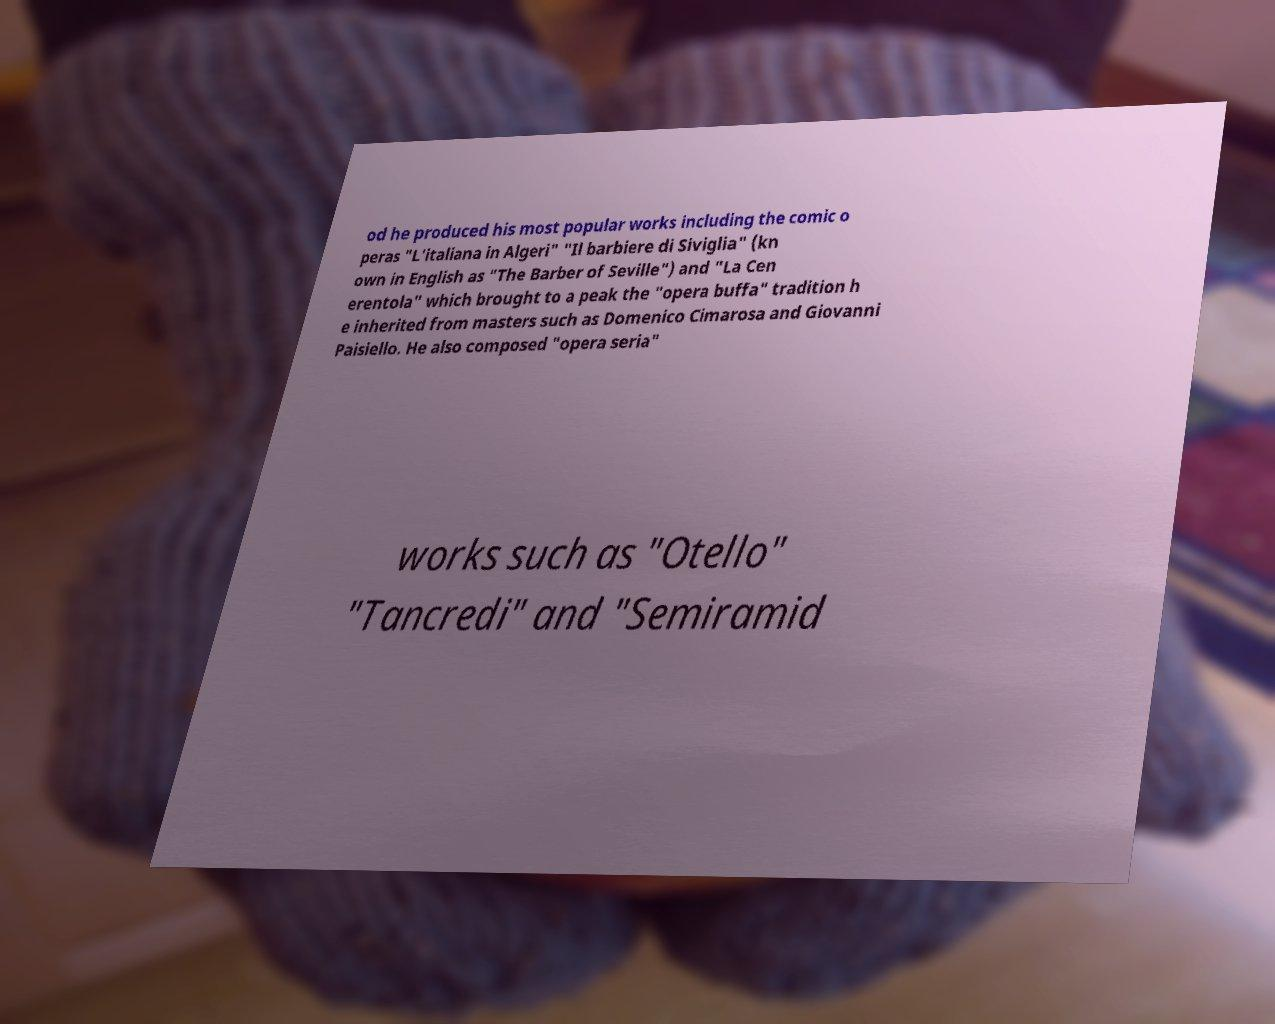There's text embedded in this image that I need extracted. Can you transcribe it verbatim? od he produced his most popular works including the comic o peras "L'italiana in Algeri" "Il barbiere di Siviglia" (kn own in English as "The Barber of Seville") and "La Cen erentola" which brought to a peak the "opera buffa" tradition h e inherited from masters such as Domenico Cimarosa and Giovanni Paisiello. He also composed "opera seria" works such as "Otello" "Tancredi" and "Semiramid 